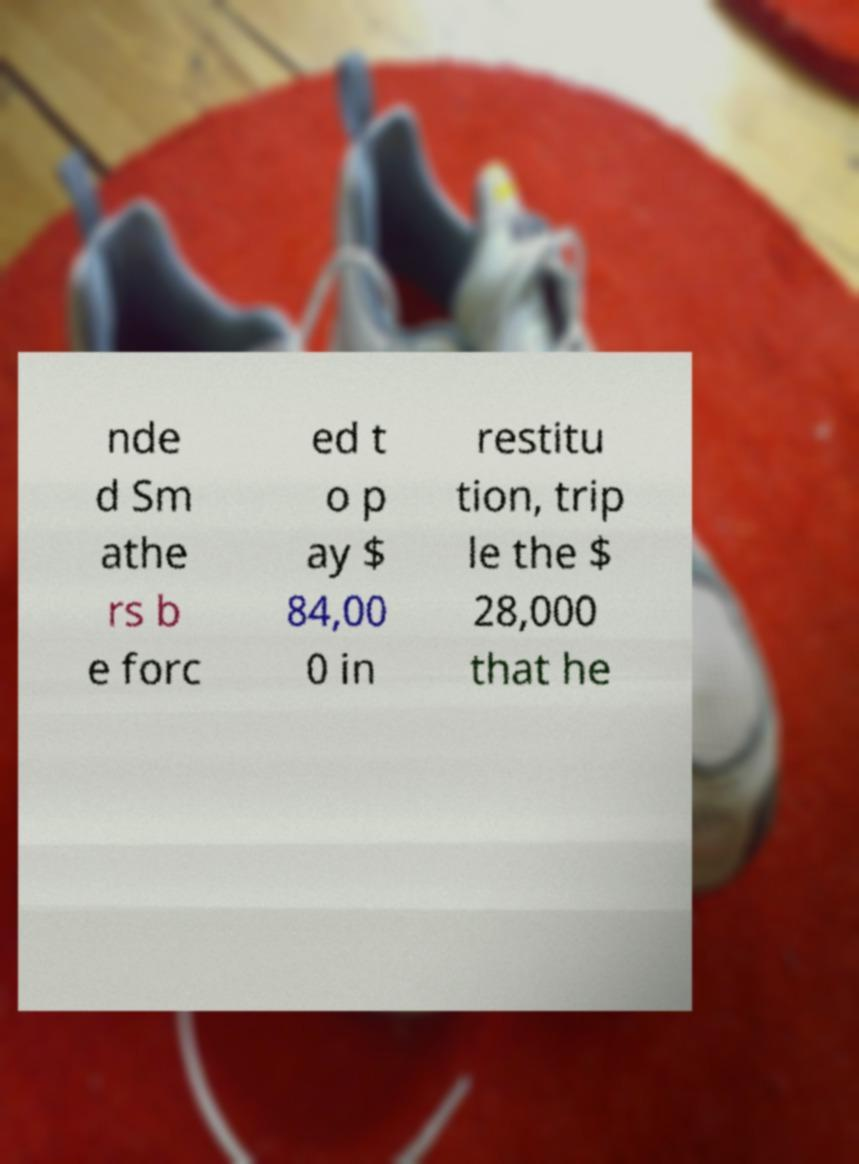There's text embedded in this image that I need extracted. Can you transcribe it verbatim? nde d Sm athe rs b e forc ed t o p ay $ 84,00 0 in restitu tion, trip le the $ 28,000 that he 